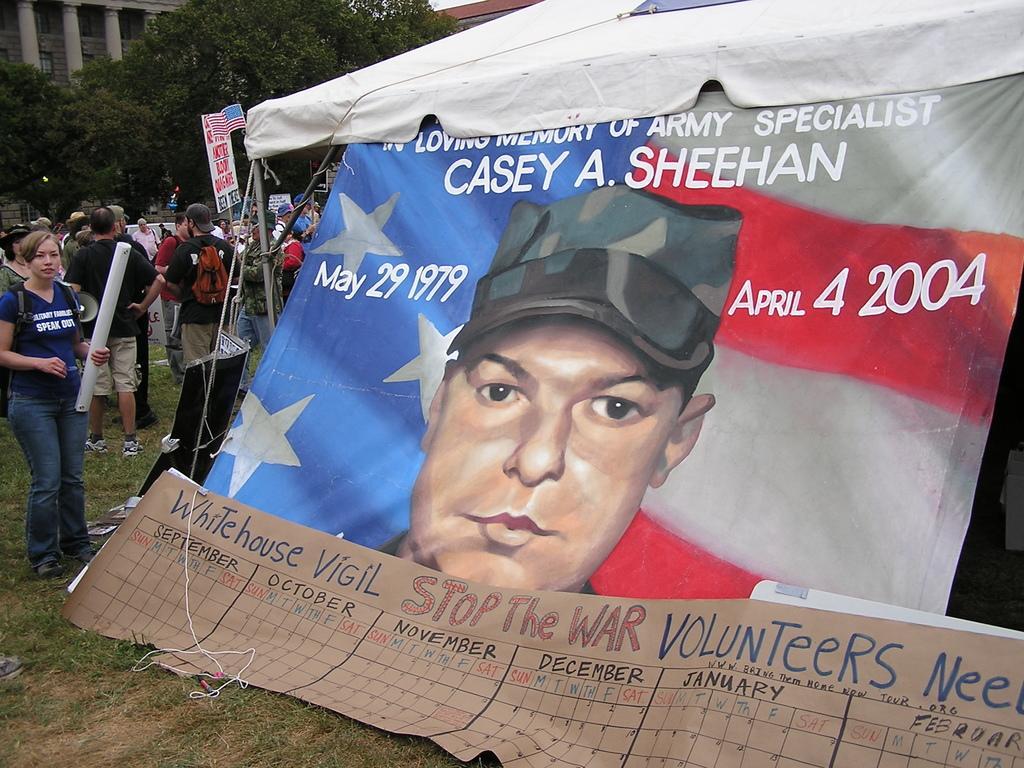How would you summarize this image in a sentence or two? In this image I can see grass ground and on it I can see number of people are standing. I can also see a pole, a board, few trees, few buildings, a flag, a tent and here I can see something is written. I can also see depiction of a human face over here. 